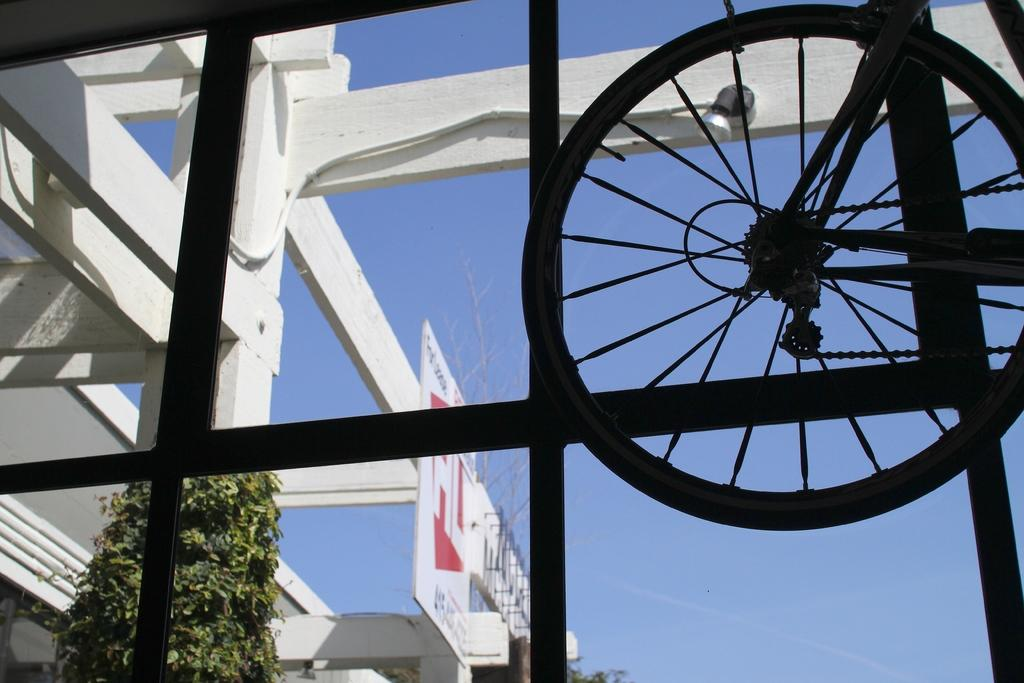What type of vehicle is associated with the wheel in the image? The wheel in the image is from a bicycle. What other mechanical components can be seen in the image? There are chains and a cable visible in the image. What type of structure has the glass windows mentioned in the image? The glass windows are part of a board, leaves, planks, light, and objects being visible through them. What can be seen outside the glass windows? The sky and objects are visible through the glass windows. How many slaves are visible through the glass windows in the image? There are no slaves visible through the glass windows in the image. What type of building is the fog coming from in the image? There is no fog or building present in the image. 